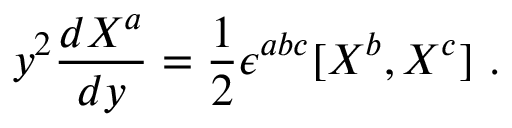<formula> <loc_0><loc_0><loc_500><loc_500>y ^ { 2 } \frac { d X ^ { a } } { d y } = \frac { 1 } { 2 } \epsilon ^ { a b c } [ X ^ { b } , X ^ { c } ] \ .</formula> 